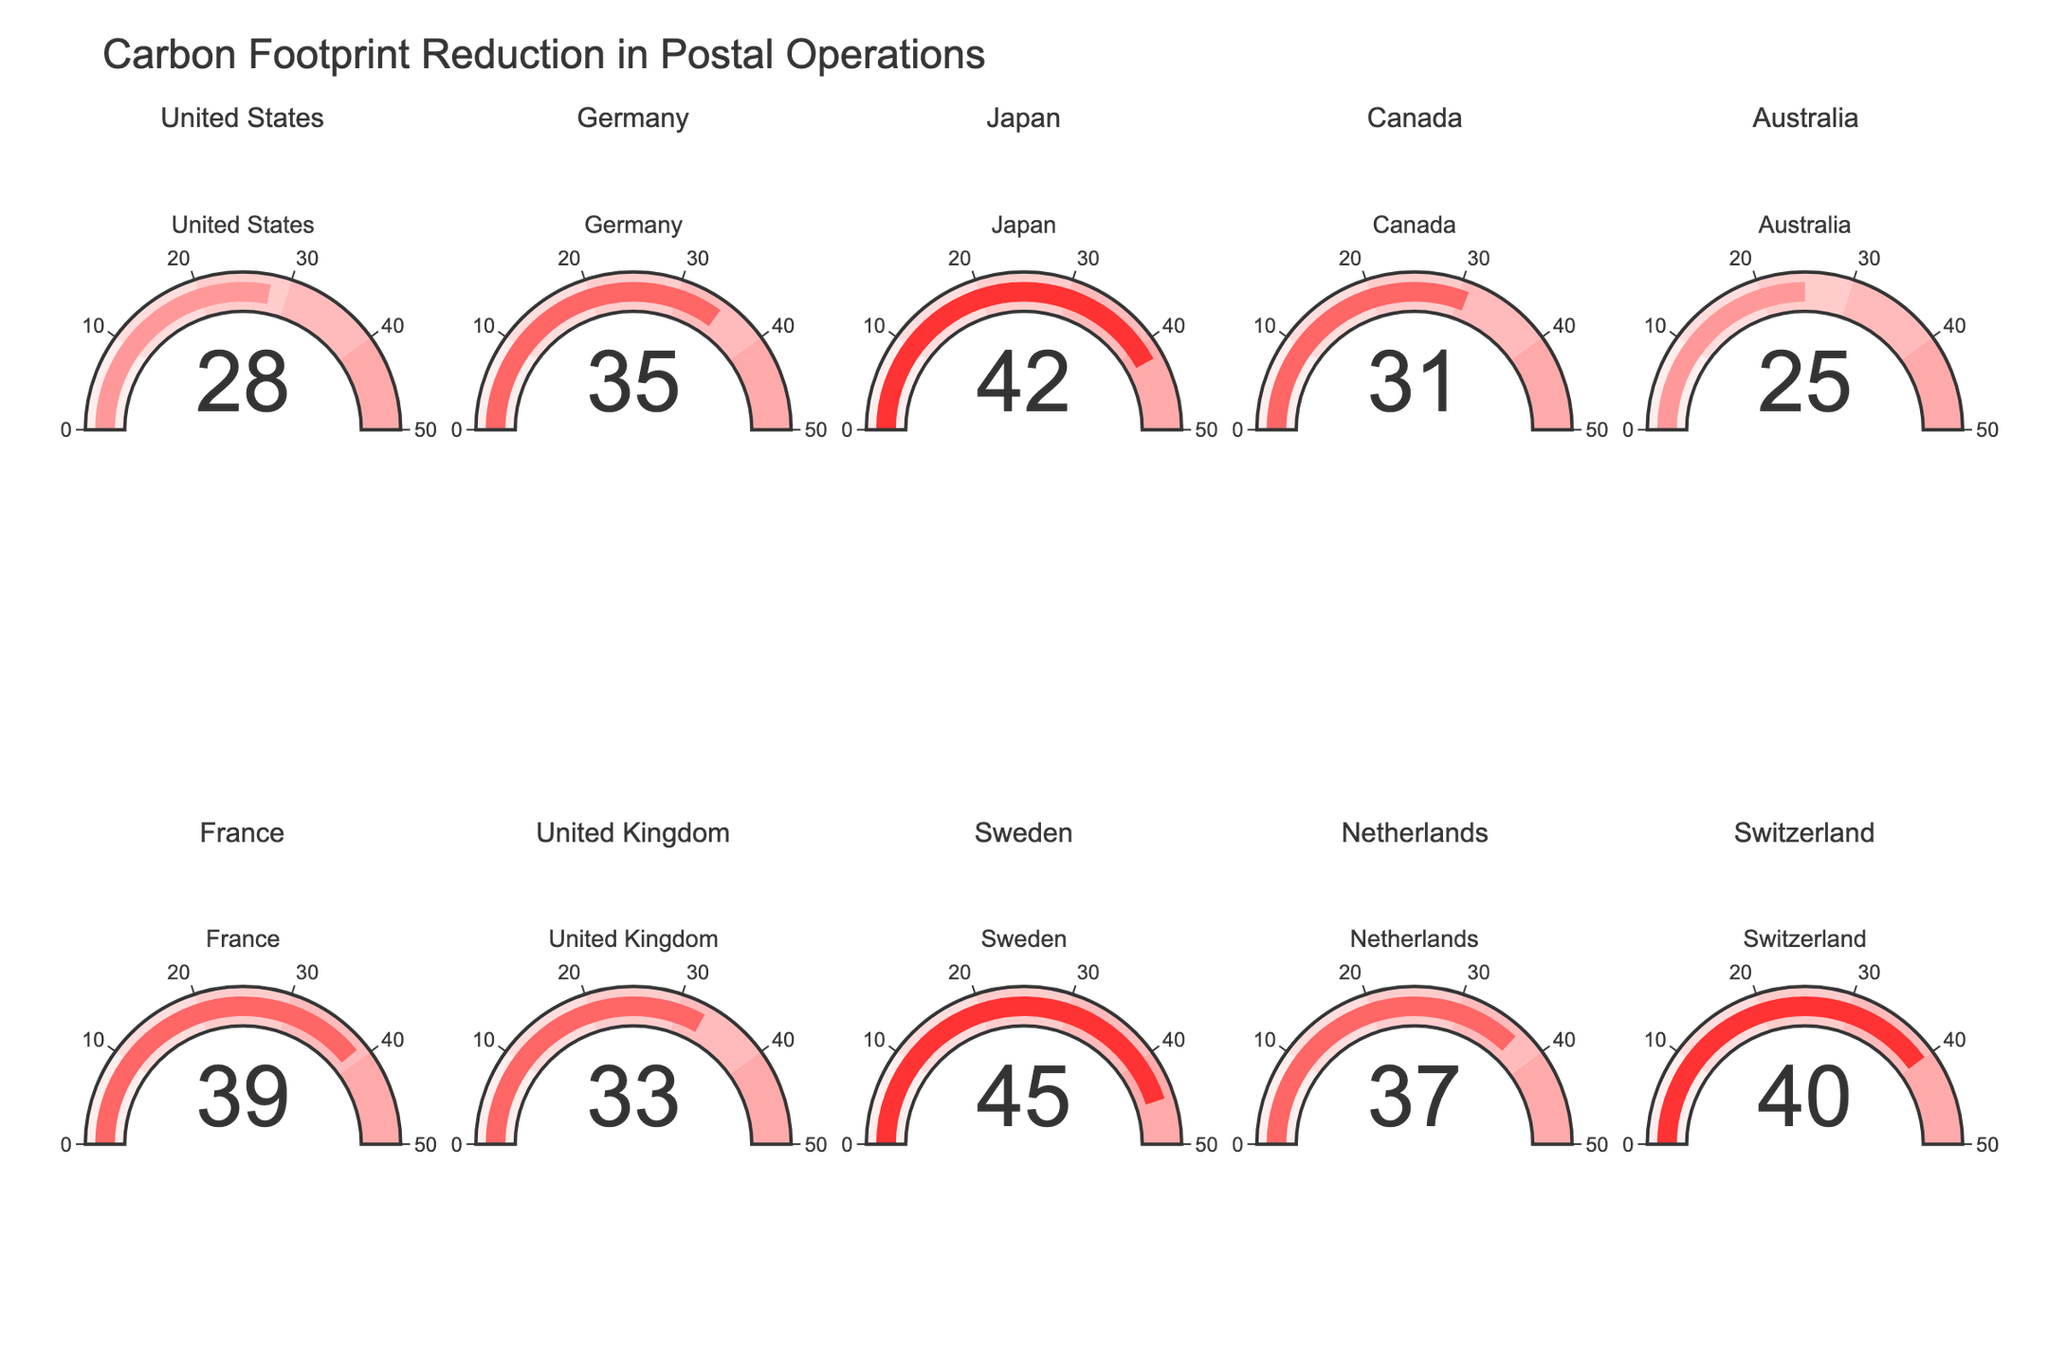what is the title of the figure? The title of the figure is displayed at the top of the chart and is typically a concise description of the data shown.
Answer: Carbon Footprint Reduction in Postal Operations How many countries are represented in the figure? Count the number of unique gauge charts or the number of subplot titles, each representing a country.
Answer: 10 Which country has the highest carbon footprint reduction? Locate the gauge with the highest value on its scale.
Answer: Sweden Which country has the lowest carbon footprint reduction? Locate the gauge with the lowest value on its scale.
Answer: Australia What is the carbon footprint reduction percentage for Canada? Find the gauge chart with the title "Canada" and note its value.
Answer: 31 How much greater is Japan's carbon footprint reduction compared to the United States? Subtract the carbon footprint reduction percentage of the United States from that of Japan (42% - 28%).
Answer: 14 Which two countries have a carbon footprint reduction above 40%? Identify gauges with values above 40% and list their respective countries.
Answer: Japan, Sweden, Switzerland What is the average carbon footprint reduction across all represented countries? Add all the percentages and divide by the total number of countries: (28 + 35 + 42 + 31 + 25 + 39 + 33 + 45 + 37 + 40) / 10.
Answer: 35.5 Do most countries have a carbon footprint reduction above or below 35%? Count the number of countries with values above 35% and compare to those below 35%.
Answer: Below What is the difference in carbon footprint reduction between France and the United Kingdom? Subtract the reduction percentage of the United Kingdom from that of France (39% - 33%).
Answer: 6 